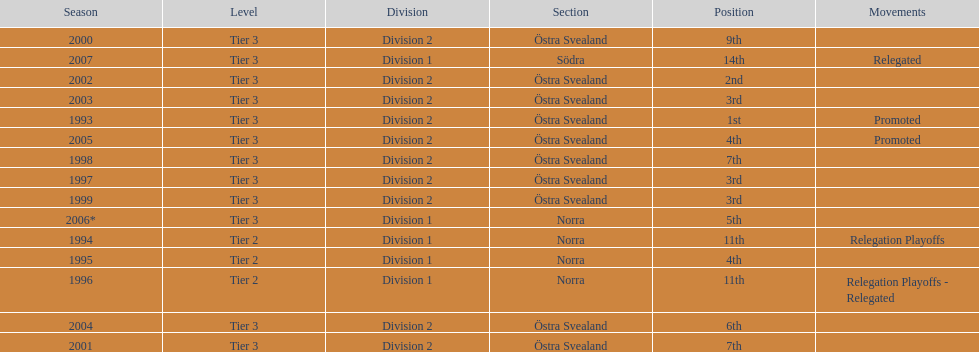Which year was more successful, 2007 or 2002? 2002. 